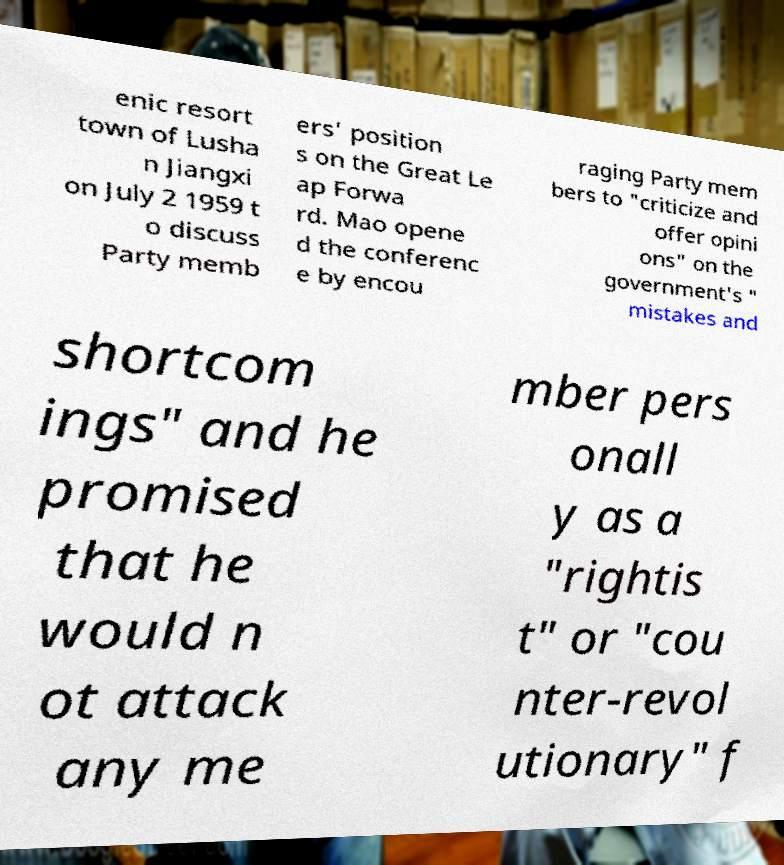Can you accurately transcribe the text from the provided image for me? enic resort town of Lusha n Jiangxi on July 2 1959 t o discuss Party memb ers' position s on the Great Le ap Forwa rd. Mao opene d the conferenc e by encou raging Party mem bers to "criticize and offer opini ons" on the government's " mistakes and shortcom ings" and he promised that he would n ot attack any me mber pers onall y as a "rightis t" or "cou nter-revol utionary" f 